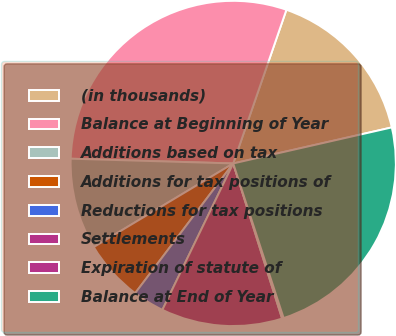Convert chart to OTSL. <chart><loc_0><loc_0><loc_500><loc_500><pie_chart><fcel>(in thousands)<fcel>Balance at Beginning of Year<fcel>Additions based on tax<fcel>Additions for tax positions of<fcel>Reductions for tax positions<fcel>Settlements<fcel>Expiration of statute of<fcel>Balance at End of Year<nl><fcel>16.14%<fcel>29.84%<fcel>9.06%<fcel>6.1%<fcel>3.13%<fcel>12.03%<fcel>0.16%<fcel>23.54%<nl></chart> 